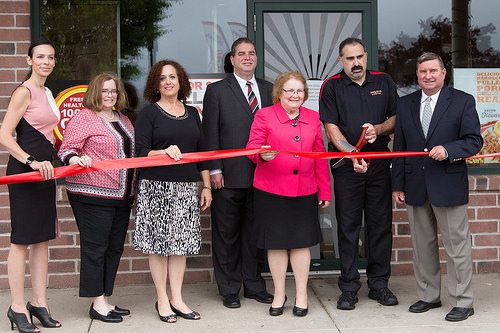<image>
Is the woman behind the ribbon? Yes. From this viewpoint, the woman is positioned behind the ribbon, with the ribbon partially or fully occluding the woman. Is the woman to the right of the man? Yes. From this viewpoint, the woman is positioned to the right side relative to the man. 